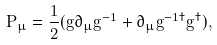<formula> <loc_0><loc_0><loc_500><loc_500>P _ { \mu } = { \frac { 1 } { 2 } } ( g \partial _ { \mu } g ^ { - 1 } + \partial _ { \mu } g ^ { - 1 \dagger } g ^ { \dagger } ) ,</formula> 